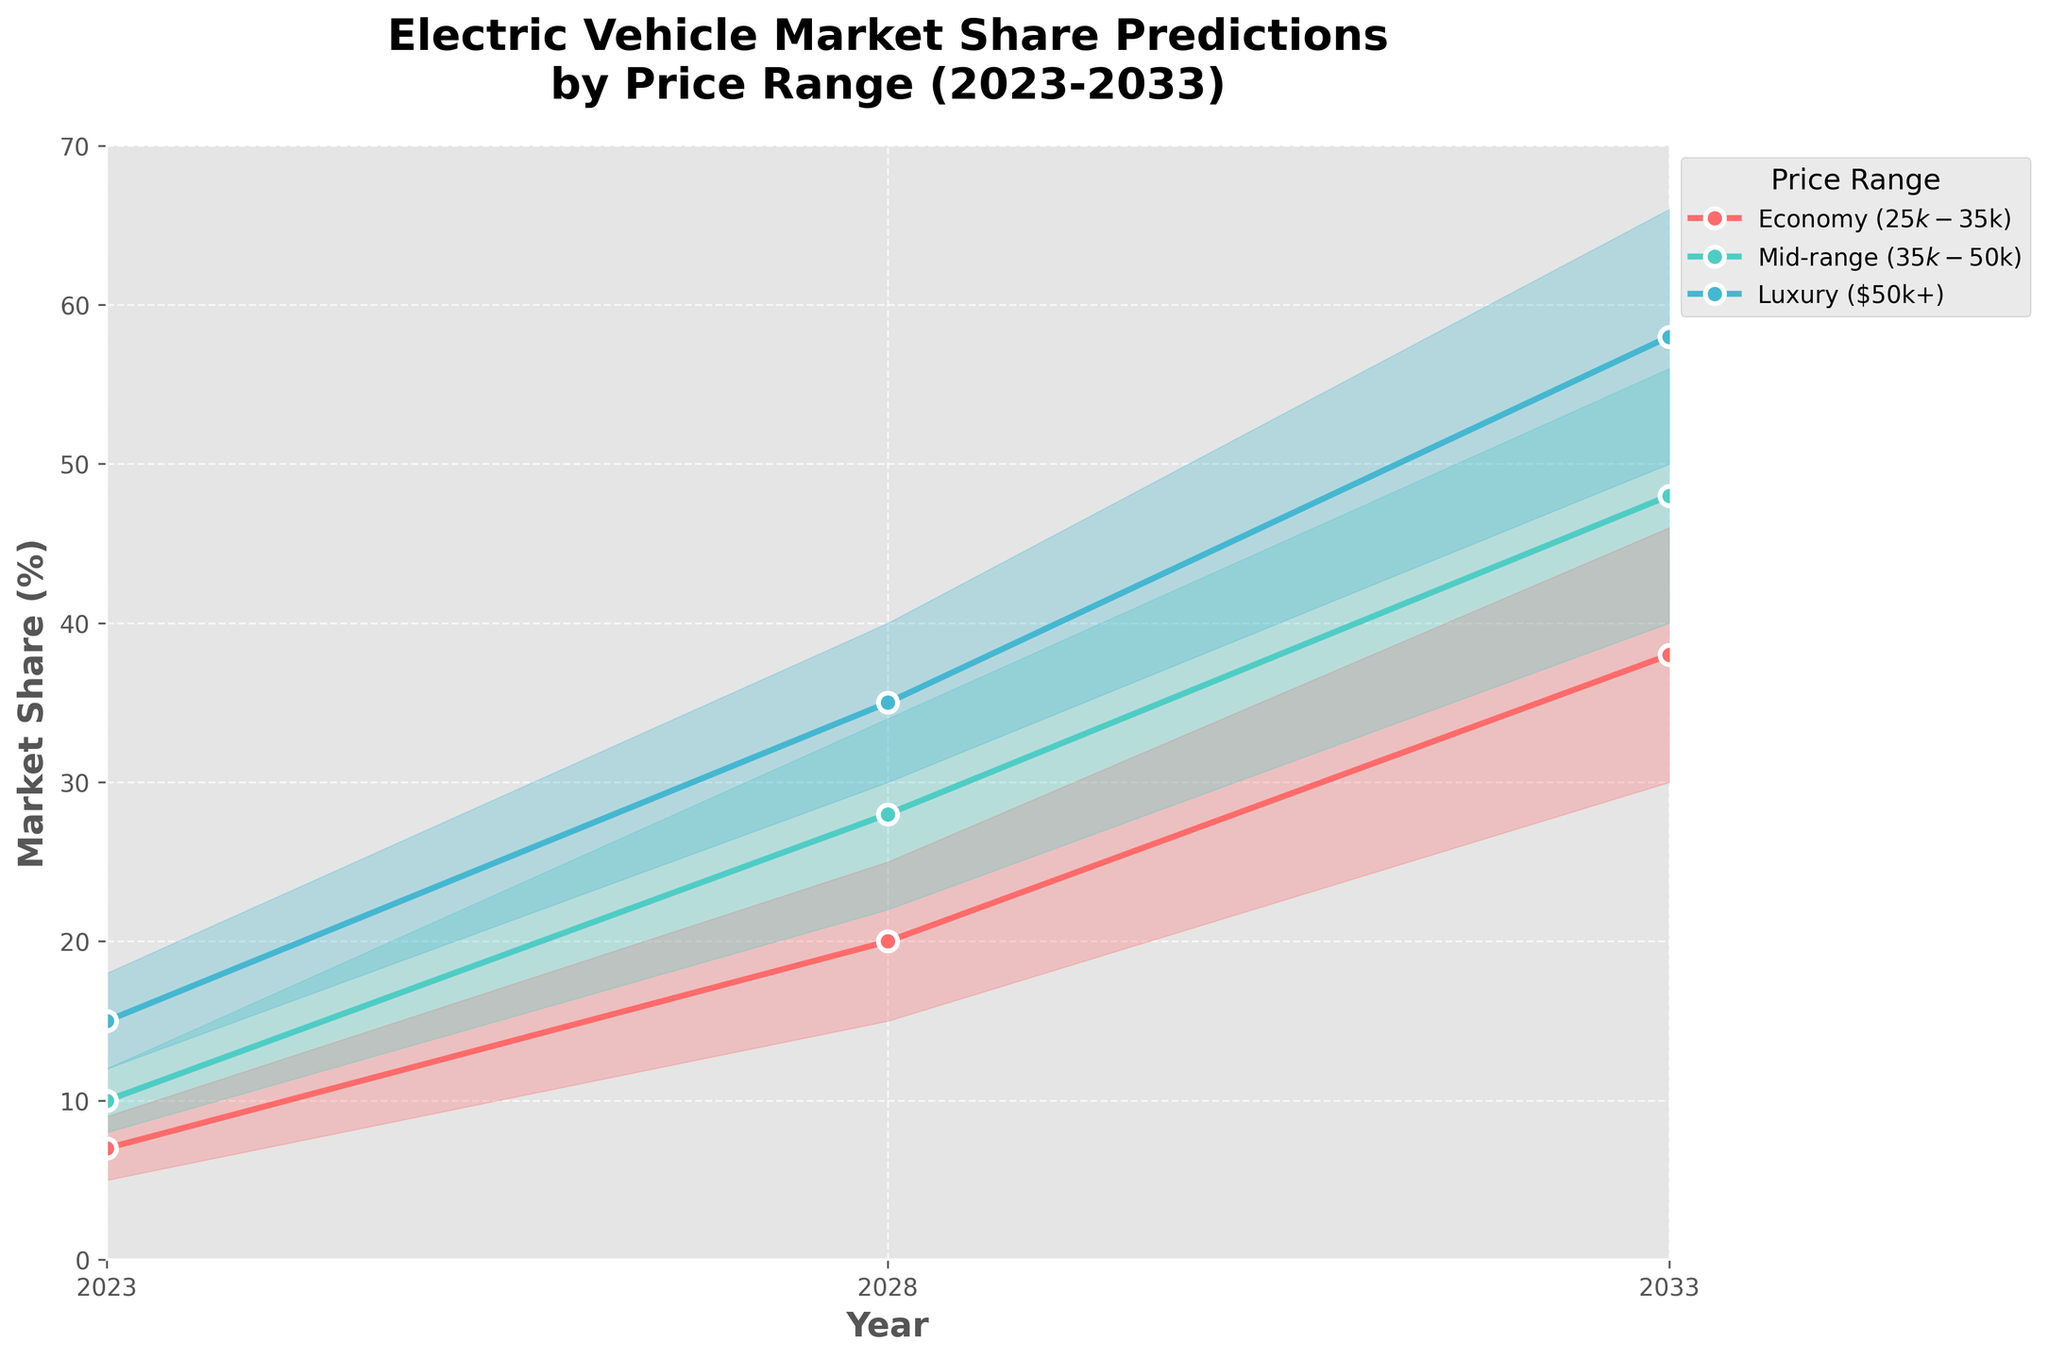What is the title of the figure? The title is at the top of the figure, typically in a larger and bolder font than other text elements.
Answer: Electric Vehicle Market Share Predictions by Price Range (2023-2033) What are the price ranges included in the figure? The price ranges are listed in the legend and each has a unique color associated with it.
Answer: Economy ($25k-$35k), Mid-range ($35k-$50k), Luxury ($50k+) Which price range is predicted to have the highest market share by 2033? Look at the data points for 2033 and identify the highest values among the price ranges. The luxury price range has the highest upper bound of 66%.
Answer: Luxury ($50k+) What is the predicted medium estimate market share for Mid-range electric vehicles in 2028? Find the line associated with the Mid-range price and locate the value for 2028, which is directly indicated.
Answer: 28% How do the market share predictions for Economy vehicles change from 2023 to 2033? Identify the values for Economy vehicles in the years 2023 and 2033, then describe the change. The 2023 estimates are (5%, 7%, 9%) and 2033 estimates are (30%, 38%, 46%). This shows a significant increase in market share.
Answer: They increase significantly Which year has the smallest difference between the low and high estimates for all price ranges? Calculate the differences between low and high estimates for each year and compare them. Looking at the data and the plot, differences in 2023 are smaller than those in 2028 and 2033 across all price ranges.
Answer: 2023 What is the growth in the medium estimate market share for Luxury vehicles from 2023 to 2033? Subtract the 2023 medium estimate for Luxury vehicles from the 2033 medium estimate. The values are 15% in 2023 and 58% in 2033.
Answer: 43% Which price range has the widest uncertainty (difference between low and high estimates) in 2033? For each price range in 2033, calculate the difference between the low and high estimates. The differences are 16% for Economy, 16% for Mid-range, and 16% for Luxury.
Answer: All have the same uncertainty Are the medium estimate market shares for all three price ranges predicted to surpass 20% by 2028? Check the medium estimate values for all price ranges in 2028. They are 20%, 28%, and 35% for Economy, Mid-range, and Luxury respectively.
Answer: Yes 